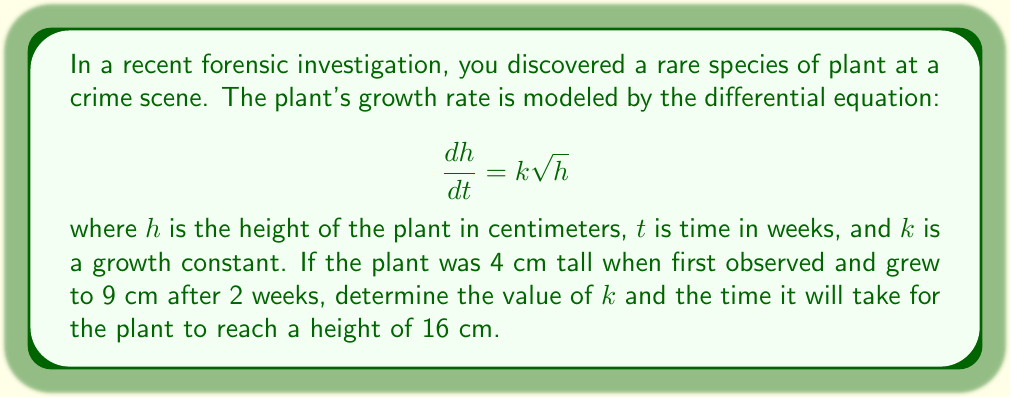Help me with this question. To solve this problem, we'll follow these steps:

1) First, we need to solve the differential equation:
   $$\frac{dh}{dt} = k\sqrt{h}$$

   Separating variables:
   $$\frac{dh}{\sqrt{h}} = k dt$$

   Integrating both sides:
   $$\int \frac{dh}{\sqrt{h}} = \int k dt$$
   $$2\sqrt{h} = kt + C$$

2) Now we can use the initial condition: $h = 4$ when $t = 0$
   $$2\sqrt{4} = k(0) + C$$
   $$4 = C$$

   So our general solution is:
   $$2\sqrt{h} = kt + 4$$

3) We can use the second condition to find $k$:
   When $t = 2$, $h = 9$
   $$2\sqrt{9} = k(2) + 4$$
   $$6 = 2k + 4$$
   $$2 = 2k$$
   $$k = 1$$

4) Now that we know $k$, we can use the equation to find when $h = 16$:
   $$2\sqrt{16} = 1t + 4$$
   $$8 = t + 4$$
   $$t = 4$$

Therefore, it will take 4 weeks for the plant to reach a height of 16 cm.
Answer: $k = 1$ and it will take 4 weeks for the plant to reach a height of 16 cm. 